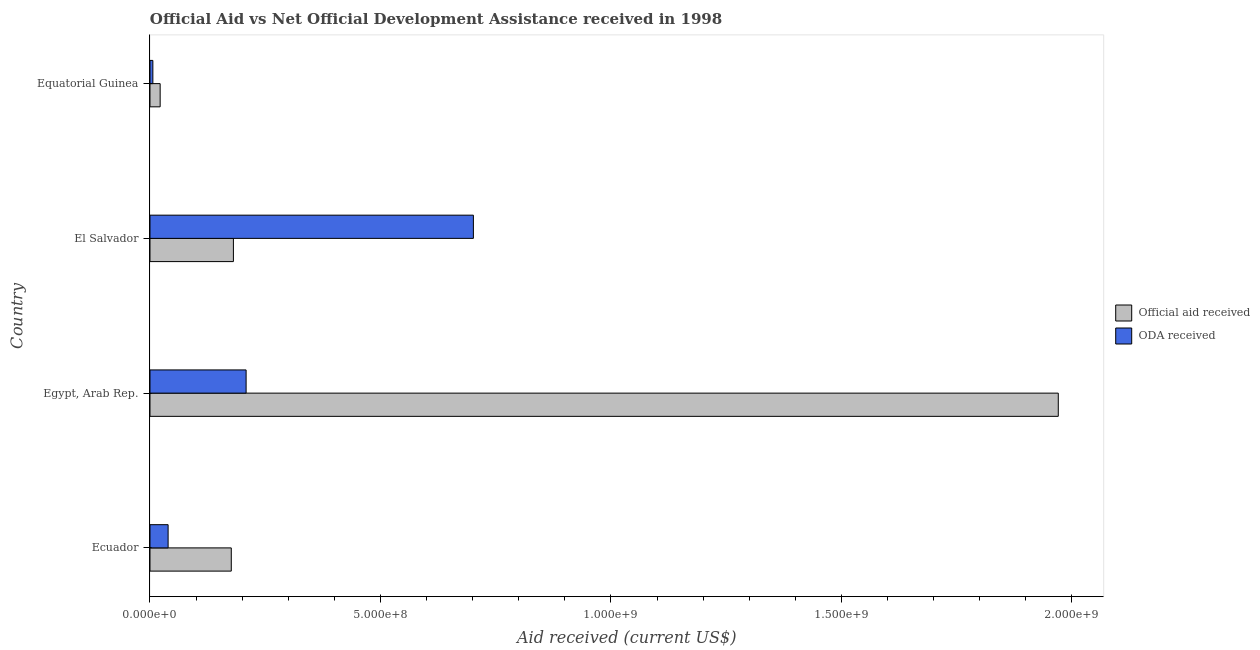Are the number of bars on each tick of the Y-axis equal?
Offer a very short reply. Yes. How many bars are there on the 3rd tick from the top?
Provide a succinct answer. 2. What is the label of the 2nd group of bars from the top?
Make the answer very short. El Salvador. In how many cases, is the number of bars for a given country not equal to the number of legend labels?
Make the answer very short. 0. What is the official aid received in El Salvador?
Your answer should be compact. 1.81e+08. Across all countries, what is the maximum oda received?
Offer a very short reply. 7.02e+08. Across all countries, what is the minimum oda received?
Keep it short and to the point. 6.22e+06. In which country was the official aid received maximum?
Give a very brief answer. Egypt, Arab Rep. In which country was the official aid received minimum?
Your answer should be compact. Equatorial Guinea. What is the total oda received in the graph?
Provide a succinct answer. 9.56e+08. What is the difference between the official aid received in Ecuador and that in Egypt, Arab Rep.?
Offer a very short reply. -1.79e+09. What is the difference between the oda received in Egypt, Arab Rep. and the official aid received in El Salvador?
Your response must be concise. 2.76e+07. What is the average oda received per country?
Offer a very short reply. 2.39e+08. What is the difference between the oda received and official aid received in Ecuador?
Your response must be concise. -1.37e+08. In how many countries, is the official aid received greater than 800000000 US$?
Your response must be concise. 1. What is the ratio of the oda received in Egypt, Arab Rep. to that in Equatorial Guinea?
Provide a short and direct response. 33.52. What is the difference between the highest and the second highest oda received?
Offer a very short reply. 4.93e+08. What is the difference between the highest and the lowest oda received?
Keep it short and to the point. 6.95e+08. In how many countries, is the oda received greater than the average oda received taken over all countries?
Your response must be concise. 1. Is the sum of the oda received in Egypt, Arab Rep. and El Salvador greater than the maximum official aid received across all countries?
Provide a succinct answer. No. What does the 1st bar from the top in Ecuador represents?
Your answer should be compact. ODA received. What does the 1st bar from the bottom in Ecuador represents?
Give a very brief answer. Official aid received. How many countries are there in the graph?
Provide a short and direct response. 4. Are the values on the major ticks of X-axis written in scientific E-notation?
Provide a succinct answer. Yes. Does the graph contain any zero values?
Your answer should be very brief. No. Where does the legend appear in the graph?
Make the answer very short. Center right. How are the legend labels stacked?
Provide a succinct answer. Vertical. What is the title of the graph?
Your answer should be compact. Official Aid vs Net Official Development Assistance received in 1998 . What is the label or title of the X-axis?
Keep it short and to the point. Aid received (current US$). What is the label or title of the Y-axis?
Make the answer very short. Country. What is the Aid received (current US$) of Official aid received in Ecuador?
Make the answer very short. 1.76e+08. What is the Aid received (current US$) of ODA received in Ecuador?
Your answer should be very brief. 3.93e+07. What is the Aid received (current US$) of Official aid received in Egypt, Arab Rep.?
Make the answer very short. 1.97e+09. What is the Aid received (current US$) of ODA received in Egypt, Arab Rep.?
Offer a very short reply. 2.09e+08. What is the Aid received (current US$) of Official aid received in El Salvador?
Ensure brevity in your answer.  1.81e+08. What is the Aid received (current US$) of ODA received in El Salvador?
Offer a very short reply. 7.02e+08. What is the Aid received (current US$) in Official aid received in Equatorial Guinea?
Your response must be concise. 2.21e+07. What is the Aid received (current US$) of ODA received in Equatorial Guinea?
Your answer should be very brief. 6.22e+06. Across all countries, what is the maximum Aid received (current US$) of Official aid received?
Offer a terse response. 1.97e+09. Across all countries, what is the maximum Aid received (current US$) of ODA received?
Provide a short and direct response. 7.02e+08. Across all countries, what is the minimum Aid received (current US$) of Official aid received?
Your answer should be compact. 2.21e+07. Across all countries, what is the minimum Aid received (current US$) in ODA received?
Provide a succinct answer. 6.22e+06. What is the total Aid received (current US$) in Official aid received in the graph?
Your answer should be very brief. 2.35e+09. What is the total Aid received (current US$) of ODA received in the graph?
Make the answer very short. 9.56e+08. What is the difference between the Aid received (current US$) in Official aid received in Ecuador and that in Egypt, Arab Rep.?
Provide a succinct answer. -1.79e+09. What is the difference between the Aid received (current US$) in ODA received in Ecuador and that in Egypt, Arab Rep.?
Offer a terse response. -1.69e+08. What is the difference between the Aid received (current US$) in Official aid received in Ecuador and that in El Salvador?
Keep it short and to the point. -4.59e+06. What is the difference between the Aid received (current US$) of ODA received in Ecuador and that in El Salvador?
Keep it short and to the point. -6.62e+08. What is the difference between the Aid received (current US$) of Official aid received in Ecuador and that in Equatorial Guinea?
Give a very brief answer. 1.54e+08. What is the difference between the Aid received (current US$) in ODA received in Ecuador and that in Equatorial Guinea?
Offer a terse response. 3.31e+07. What is the difference between the Aid received (current US$) in Official aid received in Egypt, Arab Rep. and that in El Salvador?
Offer a terse response. 1.79e+09. What is the difference between the Aid received (current US$) of ODA received in Egypt, Arab Rep. and that in El Salvador?
Your answer should be very brief. -4.93e+08. What is the difference between the Aid received (current US$) of Official aid received in Egypt, Arab Rep. and that in Equatorial Guinea?
Your response must be concise. 1.95e+09. What is the difference between the Aid received (current US$) in ODA received in Egypt, Arab Rep. and that in Equatorial Guinea?
Ensure brevity in your answer.  2.02e+08. What is the difference between the Aid received (current US$) of Official aid received in El Salvador and that in Equatorial Guinea?
Keep it short and to the point. 1.59e+08. What is the difference between the Aid received (current US$) in ODA received in El Salvador and that in Equatorial Guinea?
Provide a short and direct response. 6.95e+08. What is the difference between the Aid received (current US$) in Official aid received in Ecuador and the Aid received (current US$) in ODA received in Egypt, Arab Rep.?
Provide a short and direct response. -3.22e+07. What is the difference between the Aid received (current US$) in Official aid received in Ecuador and the Aid received (current US$) in ODA received in El Salvador?
Offer a terse response. -5.25e+08. What is the difference between the Aid received (current US$) in Official aid received in Ecuador and the Aid received (current US$) in ODA received in Equatorial Guinea?
Provide a succinct answer. 1.70e+08. What is the difference between the Aid received (current US$) in Official aid received in Egypt, Arab Rep. and the Aid received (current US$) in ODA received in El Salvador?
Ensure brevity in your answer.  1.27e+09. What is the difference between the Aid received (current US$) in Official aid received in Egypt, Arab Rep. and the Aid received (current US$) in ODA received in Equatorial Guinea?
Provide a short and direct response. 1.96e+09. What is the difference between the Aid received (current US$) in Official aid received in El Salvador and the Aid received (current US$) in ODA received in Equatorial Guinea?
Your answer should be compact. 1.75e+08. What is the average Aid received (current US$) in Official aid received per country?
Keep it short and to the point. 5.87e+08. What is the average Aid received (current US$) in ODA received per country?
Your answer should be very brief. 2.39e+08. What is the difference between the Aid received (current US$) of Official aid received and Aid received (current US$) of ODA received in Ecuador?
Offer a terse response. 1.37e+08. What is the difference between the Aid received (current US$) of Official aid received and Aid received (current US$) of ODA received in Egypt, Arab Rep.?
Keep it short and to the point. 1.76e+09. What is the difference between the Aid received (current US$) of Official aid received and Aid received (current US$) of ODA received in El Salvador?
Your answer should be very brief. -5.21e+08. What is the difference between the Aid received (current US$) in Official aid received and Aid received (current US$) in ODA received in Equatorial Guinea?
Ensure brevity in your answer.  1.58e+07. What is the ratio of the Aid received (current US$) of Official aid received in Ecuador to that in Egypt, Arab Rep.?
Offer a terse response. 0.09. What is the ratio of the Aid received (current US$) of ODA received in Ecuador to that in Egypt, Arab Rep.?
Make the answer very short. 0.19. What is the ratio of the Aid received (current US$) in Official aid received in Ecuador to that in El Salvador?
Ensure brevity in your answer.  0.97. What is the ratio of the Aid received (current US$) in ODA received in Ecuador to that in El Salvador?
Your answer should be compact. 0.06. What is the ratio of the Aid received (current US$) of Official aid received in Ecuador to that in Equatorial Guinea?
Ensure brevity in your answer.  7.99. What is the ratio of the Aid received (current US$) in ODA received in Ecuador to that in Equatorial Guinea?
Provide a succinct answer. 6.32. What is the ratio of the Aid received (current US$) in Official aid received in Egypt, Arab Rep. to that in El Salvador?
Provide a succinct answer. 10.89. What is the ratio of the Aid received (current US$) of ODA received in Egypt, Arab Rep. to that in El Salvador?
Make the answer very short. 0.3. What is the ratio of the Aid received (current US$) in Official aid received in Egypt, Arab Rep. to that in Equatorial Guinea?
Offer a very short reply. 89.32. What is the ratio of the Aid received (current US$) in ODA received in Egypt, Arab Rep. to that in Equatorial Guinea?
Your answer should be very brief. 33.52. What is the ratio of the Aid received (current US$) of Official aid received in El Salvador to that in Equatorial Guinea?
Offer a very short reply. 8.2. What is the ratio of the Aid received (current US$) in ODA received in El Salvador to that in Equatorial Guinea?
Your answer should be very brief. 112.79. What is the difference between the highest and the second highest Aid received (current US$) of Official aid received?
Provide a succinct answer. 1.79e+09. What is the difference between the highest and the second highest Aid received (current US$) in ODA received?
Give a very brief answer. 4.93e+08. What is the difference between the highest and the lowest Aid received (current US$) in Official aid received?
Offer a very short reply. 1.95e+09. What is the difference between the highest and the lowest Aid received (current US$) of ODA received?
Provide a succinct answer. 6.95e+08. 